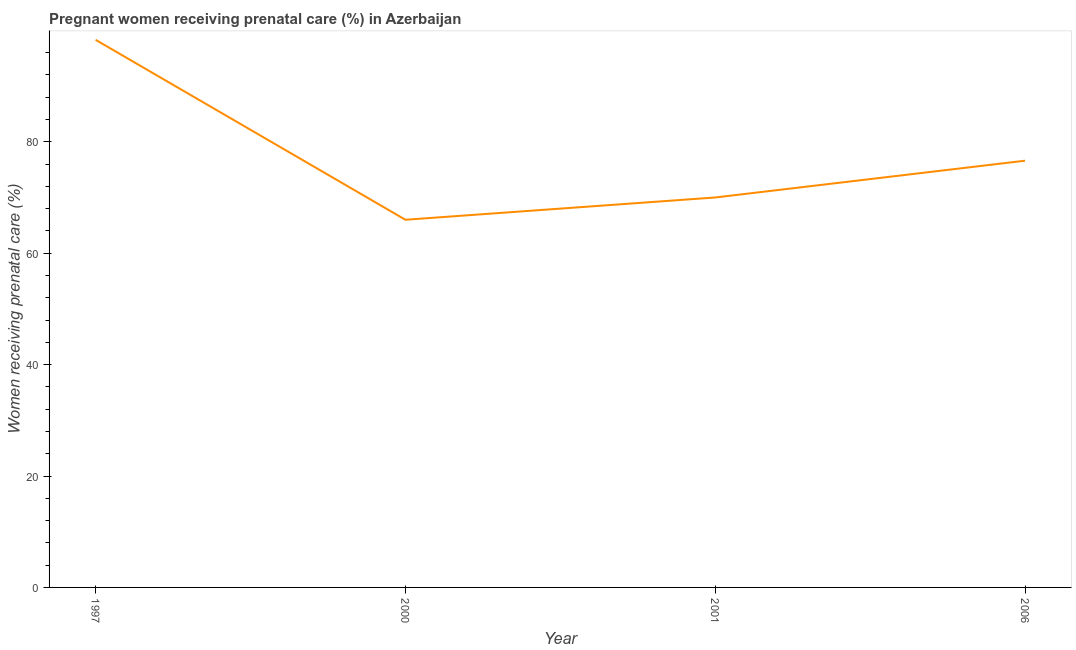Across all years, what is the maximum percentage of pregnant women receiving prenatal care?
Offer a very short reply. 98.3. Across all years, what is the minimum percentage of pregnant women receiving prenatal care?
Keep it short and to the point. 66. In which year was the percentage of pregnant women receiving prenatal care maximum?
Provide a succinct answer. 1997. In which year was the percentage of pregnant women receiving prenatal care minimum?
Your answer should be compact. 2000. What is the sum of the percentage of pregnant women receiving prenatal care?
Provide a succinct answer. 310.9. What is the difference between the percentage of pregnant women receiving prenatal care in 1997 and 2006?
Offer a terse response. 21.7. What is the average percentage of pregnant women receiving prenatal care per year?
Offer a very short reply. 77.72. What is the median percentage of pregnant women receiving prenatal care?
Offer a terse response. 73.3. In how many years, is the percentage of pregnant women receiving prenatal care greater than 24 %?
Offer a terse response. 4. Do a majority of the years between 1997 and 2000 (inclusive) have percentage of pregnant women receiving prenatal care greater than 72 %?
Ensure brevity in your answer.  No. What is the ratio of the percentage of pregnant women receiving prenatal care in 1997 to that in 2001?
Ensure brevity in your answer.  1.4. Is the difference between the percentage of pregnant women receiving prenatal care in 2000 and 2006 greater than the difference between any two years?
Your answer should be compact. No. What is the difference between the highest and the second highest percentage of pregnant women receiving prenatal care?
Your response must be concise. 21.7. What is the difference between the highest and the lowest percentage of pregnant women receiving prenatal care?
Provide a short and direct response. 32.3. How many years are there in the graph?
Offer a very short reply. 4. What is the title of the graph?
Provide a short and direct response. Pregnant women receiving prenatal care (%) in Azerbaijan. What is the label or title of the X-axis?
Your answer should be compact. Year. What is the label or title of the Y-axis?
Provide a short and direct response. Women receiving prenatal care (%). What is the Women receiving prenatal care (%) of 1997?
Give a very brief answer. 98.3. What is the Women receiving prenatal care (%) of 2001?
Keep it short and to the point. 70. What is the Women receiving prenatal care (%) of 2006?
Give a very brief answer. 76.6. What is the difference between the Women receiving prenatal care (%) in 1997 and 2000?
Offer a very short reply. 32.3. What is the difference between the Women receiving prenatal care (%) in 1997 and 2001?
Ensure brevity in your answer.  28.3. What is the difference between the Women receiving prenatal care (%) in 1997 and 2006?
Give a very brief answer. 21.7. What is the difference between the Women receiving prenatal care (%) in 2000 and 2001?
Your answer should be very brief. -4. What is the ratio of the Women receiving prenatal care (%) in 1997 to that in 2000?
Keep it short and to the point. 1.49. What is the ratio of the Women receiving prenatal care (%) in 1997 to that in 2001?
Keep it short and to the point. 1.4. What is the ratio of the Women receiving prenatal care (%) in 1997 to that in 2006?
Give a very brief answer. 1.28. What is the ratio of the Women receiving prenatal care (%) in 2000 to that in 2001?
Your answer should be very brief. 0.94. What is the ratio of the Women receiving prenatal care (%) in 2000 to that in 2006?
Ensure brevity in your answer.  0.86. What is the ratio of the Women receiving prenatal care (%) in 2001 to that in 2006?
Offer a very short reply. 0.91. 